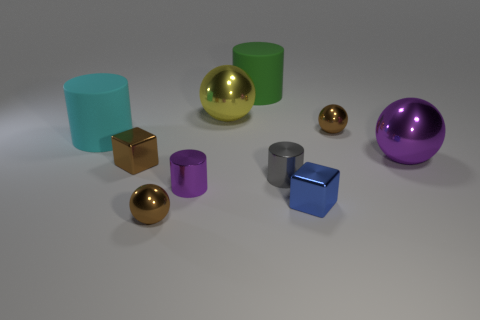There is another large object that is the same shape as the big purple object; what is it made of?
Offer a very short reply. Metal. Do the small cube that is left of the blue metallic object and the large cyan object have the same material?
Ensure brevity in your answer.  No. Is the number of tiny brown balls in front of the tiny blue object greater than the number of metallic cylinders behind the cyan matte thing?
Keep it short and to the point. Yes. What size is the purple cylinder?
Ensure brevity in your answer.  Small. There is a blue object that is the same material as the purple ball; what shape is it?
Offer a terse response. Cube. There is a small brown thing on the right side of the tiny gray metal object; does it have the same shape as the small gray metal thing?
Provide a succinct answer. No. How many things are either large cylinders or big purple matte balls?
Your answer should be compact. 2. There is a brown thing that is both behind the tiny blue shiny block and to the left of the big yellow shiny thing; what material is it?
Offer a terse response. Metal. Do the yellow object and the purple metallic sphere have the same size?
Your answer should be very brief. Yes. There is a blue block left of the small brown shiny ball that is behind the big cyan cylinder; what is its size?
Provide a succinct answer. Small. 